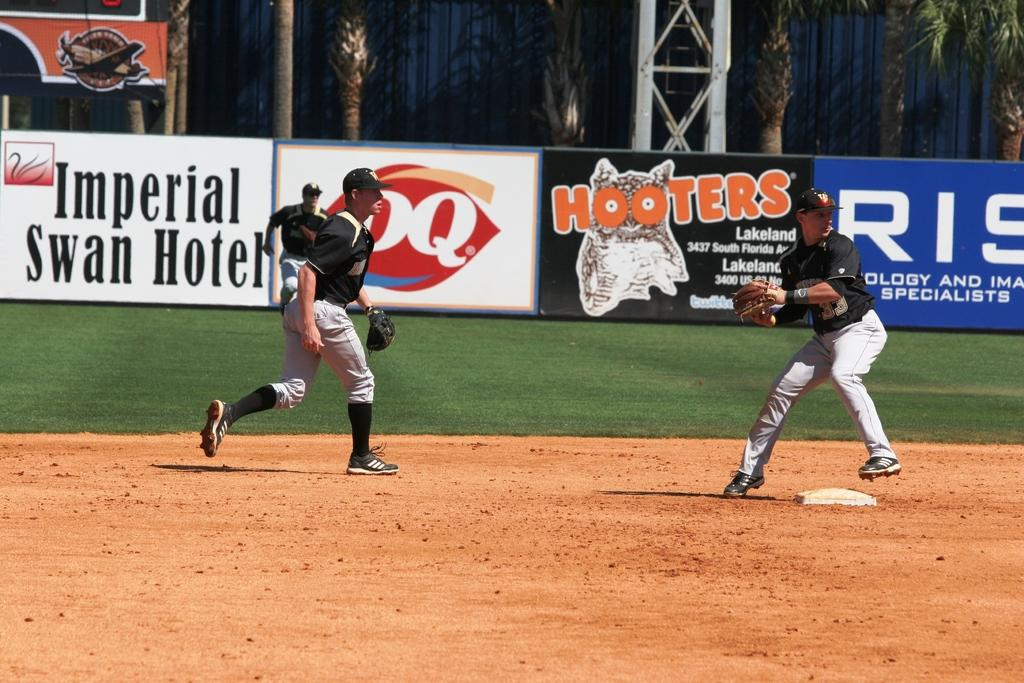<image>
Describe the image concisely. Outfield of a baseball game sponsored by Imperial Swan hotel, DQ, Hooters and others. 